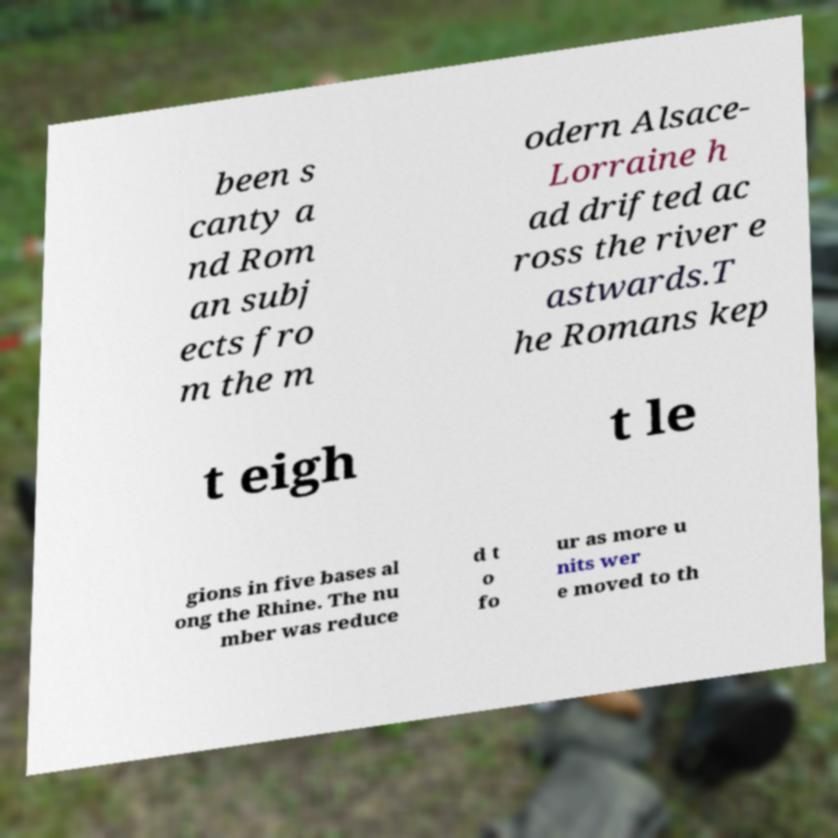Could you extract and type out the text from this image? been s canty a nd Rom an subj ects fro m the m odern Alsace- Lorraine h ad drifted ac ross the river e astwards.T he Romans kep t eigh t le gions in five bases al ong the Rhine. The nu mber was reduce d t o fo ur as more u nits wer e moved to th 